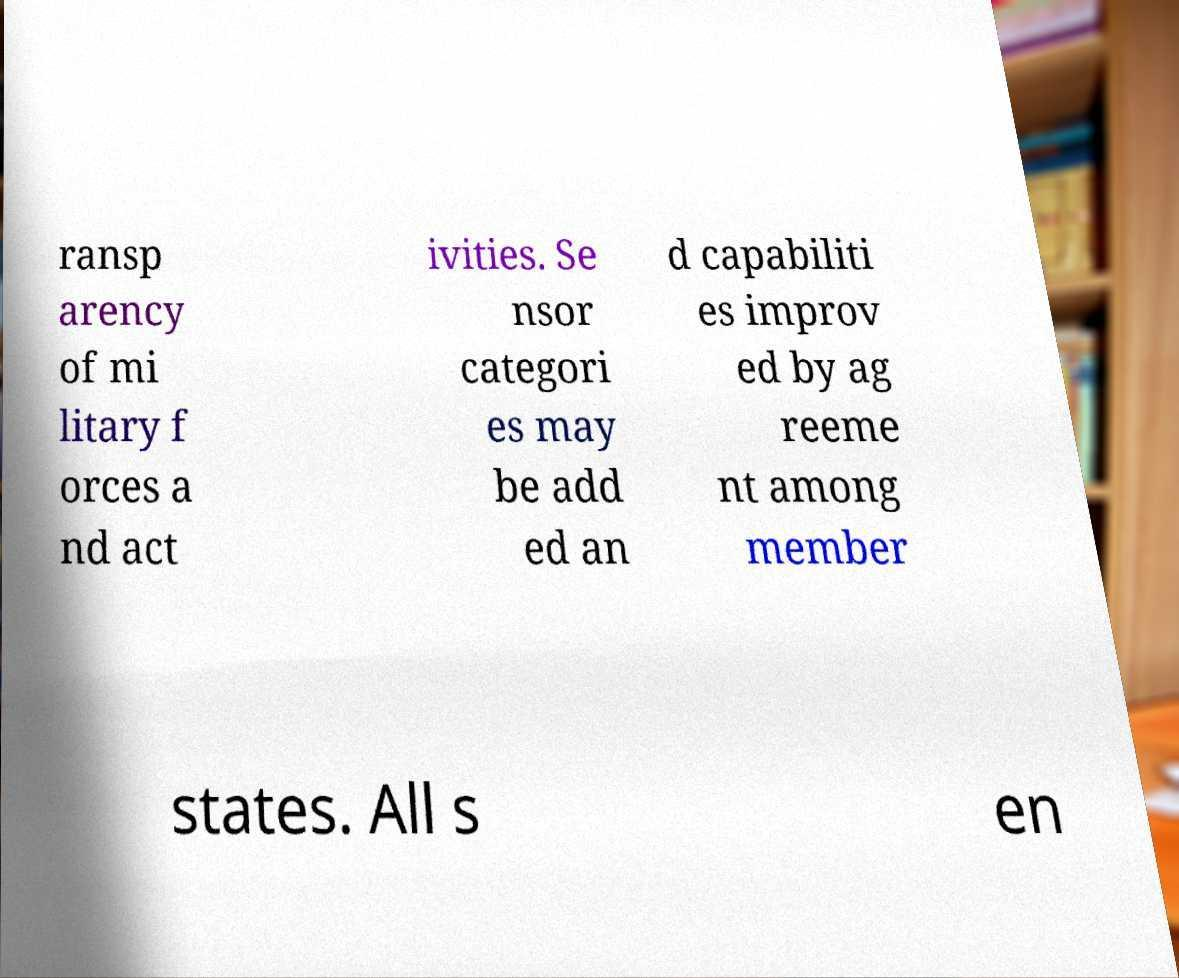Please identify and transcribe the text found in this image. ransp arency of mi litary f orces a nd act ivities. Se nsor categori es may be add ed an d capabiliti es improv ed by ag reeme nt among member states. All s en 